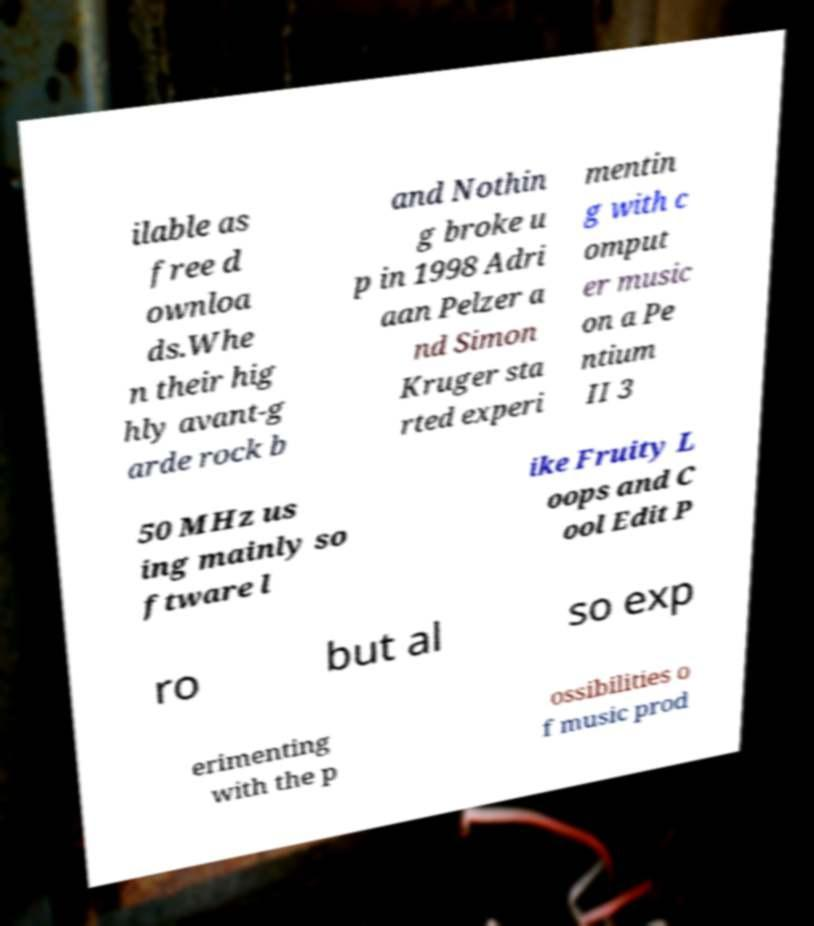I need the written content from this picture converted into text. Can you do that? ilable as free d ownloa ds.Whe n their hig hly avant-g arde rock b and Nothin g broke u p in 1998 Adri aan Pelzer a nd Simon Kruger sta rted experi mentin g with c omput er music on a Pe ntium II 3 50 MHz us ing mainly so ftware l ike Fruity L oops and C ool Edit P ro but al so exp erimenting with the p ossibilities o f music prod 